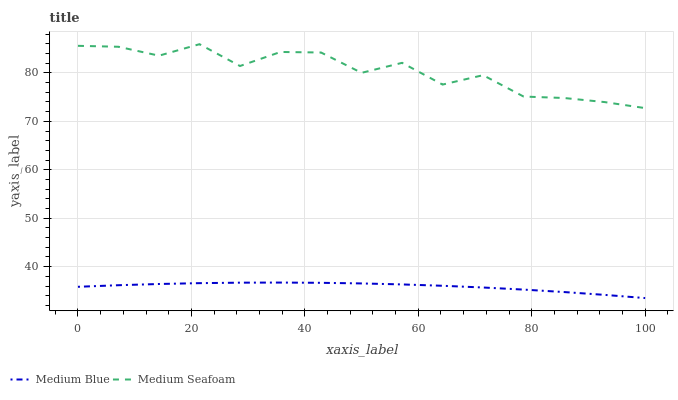Does Medium Blue have the minimum area under the curve?
Answer yes or no. Yes. Does Medium Seafoam have the maximum area under the curve?
Answer yes or no. Yes. Does Medium Seafoam have the minimum area under the curve?
Answer yes or no. No. Is Medium Blue the smoothest?
Answer yes or no. Yes. Is Medium Seafoam the roughest?
Answer yes or no. Yes. Is Medium Seafoam the smoothest?
Answer yes or no. No. Does Medium Blue have the lowest value?
Answer yes or no. Yes. Does Medium Seafoam have the lowest value?
Answer yes or no. No. Does Medium Seafoam have the highest value?
Answer yes or no. Yes. Is Medium Blue less than Medium Seafoam?
Answer yes or no. Yes. Is Medium Seafoam greater than Medium Blue?
Answer yes or no. Yes. Does Medium Blue intersect Medium Seafoam?
Answer yes or no. No. 